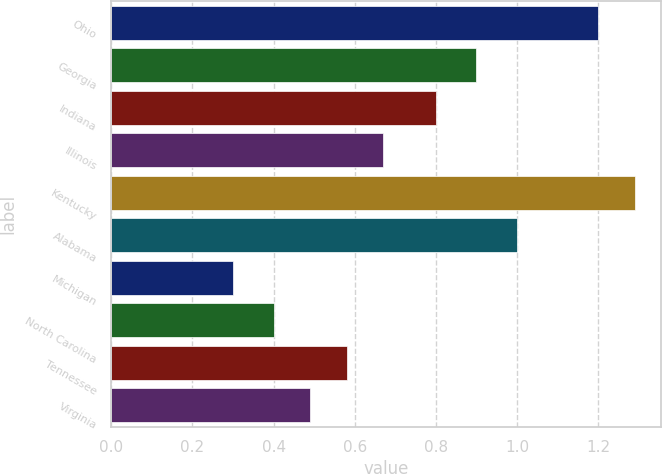<chart> <loc_0><loc_0><loc_500><loc_500><bar_chart><fcel>Ohio<fcel>Georgia<fcel>Indiana<fcel>Illinois<fcel>Kentucky<fcel>Alabama<fcel>Michigan<fcel>North Carolina<fcel>Tennessee<fcel>Virginia<nl><fcel>1.2<fcel>0.9<fcel>0.8<fcel>0.67<fcel>1.29<fcel>1<fcel>0.3<fcel>0.4<fcel>0.58<fcel>0.49<nl></chart> 